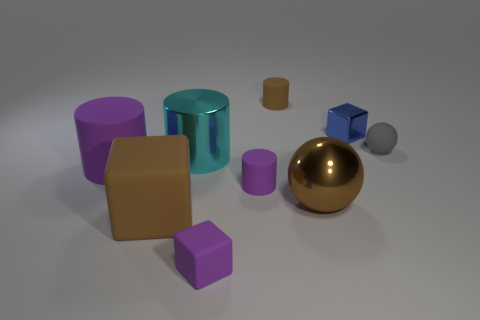Are there an equal number of big shiny spheres that are right of the big brown metal thing and cyan metal cylinders?
Make the answer very short. No. How many rubber cylinders are both on the right side of the purple matte cube and in front of the large metallic cylinder?
Offer a very short reply. 1. There is a blue object that is the same material as the large cyan cylinder; what size is it?
Provide a succinct answer. Small. How many other small blue objects have the same shape as the small blue metal thing?
Your answer should be very brief. 0. Are there more small objects on the right side of the shiny block than large purple cylinders?
Make the answer very short. No. What is the shape of the purple rubber thing that is behind the large ball and left of the small purple matte cylinder?
Your response must be concise. Cylinder. Do the brown metal sphere and the gray thing have the same size?
Your response must be concise. No. What number of small rubber objects are left of the small gray rubber thing?
Provide a short and direct response. 3. Is the number of tiny gray rubber spheres behind the gray ball the same as the number of things to the left of the brown cylinder?
Your answer should be very brief. No. There is a tiny thing that is behind the tiny blue thing; is its shape the same as the cyan object?
Provide a succinct answer. Yes. 